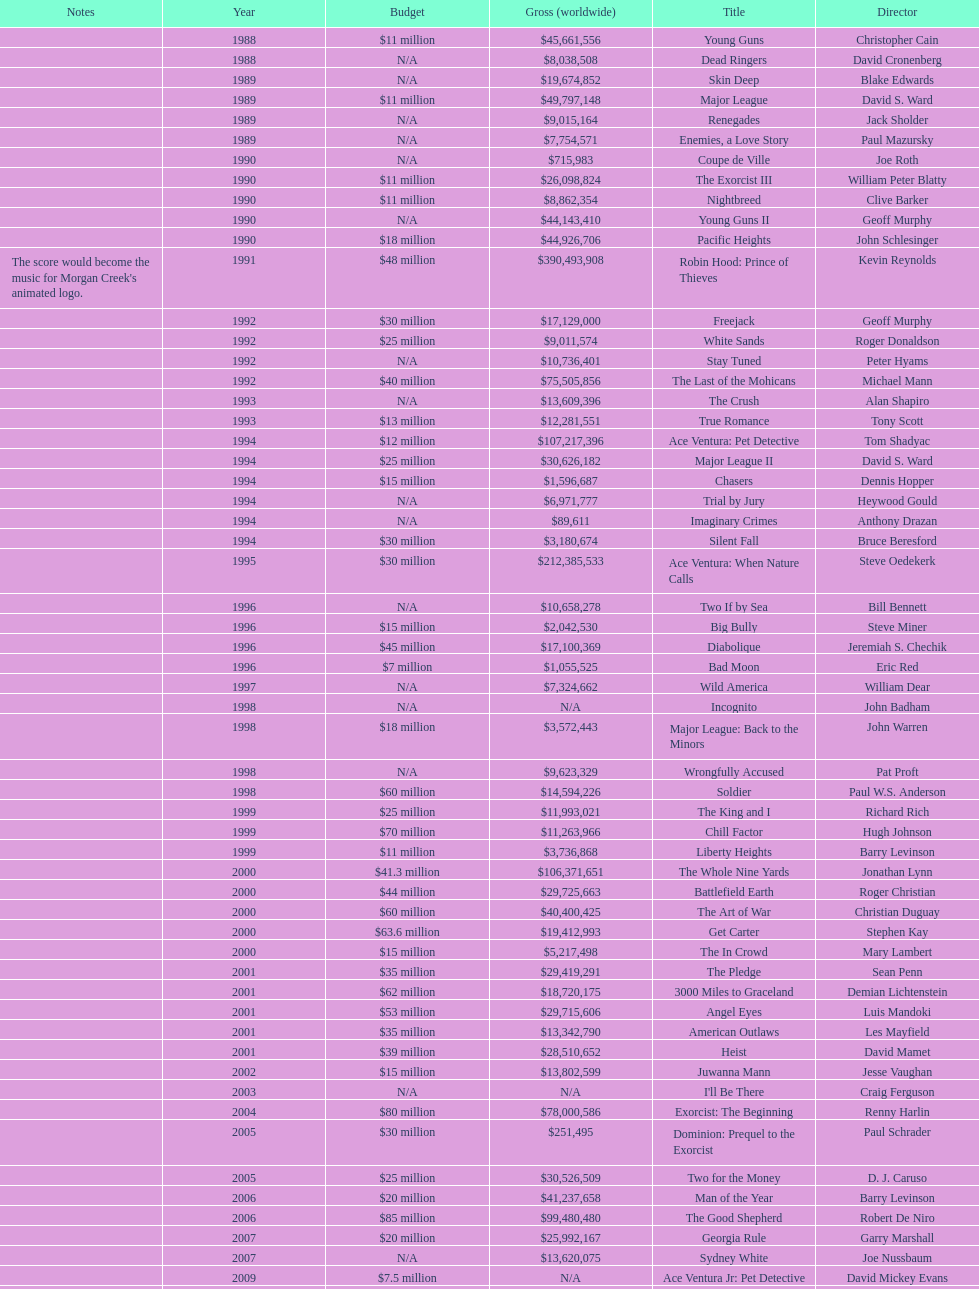How many films did morgan creek make in 2006? 2. 